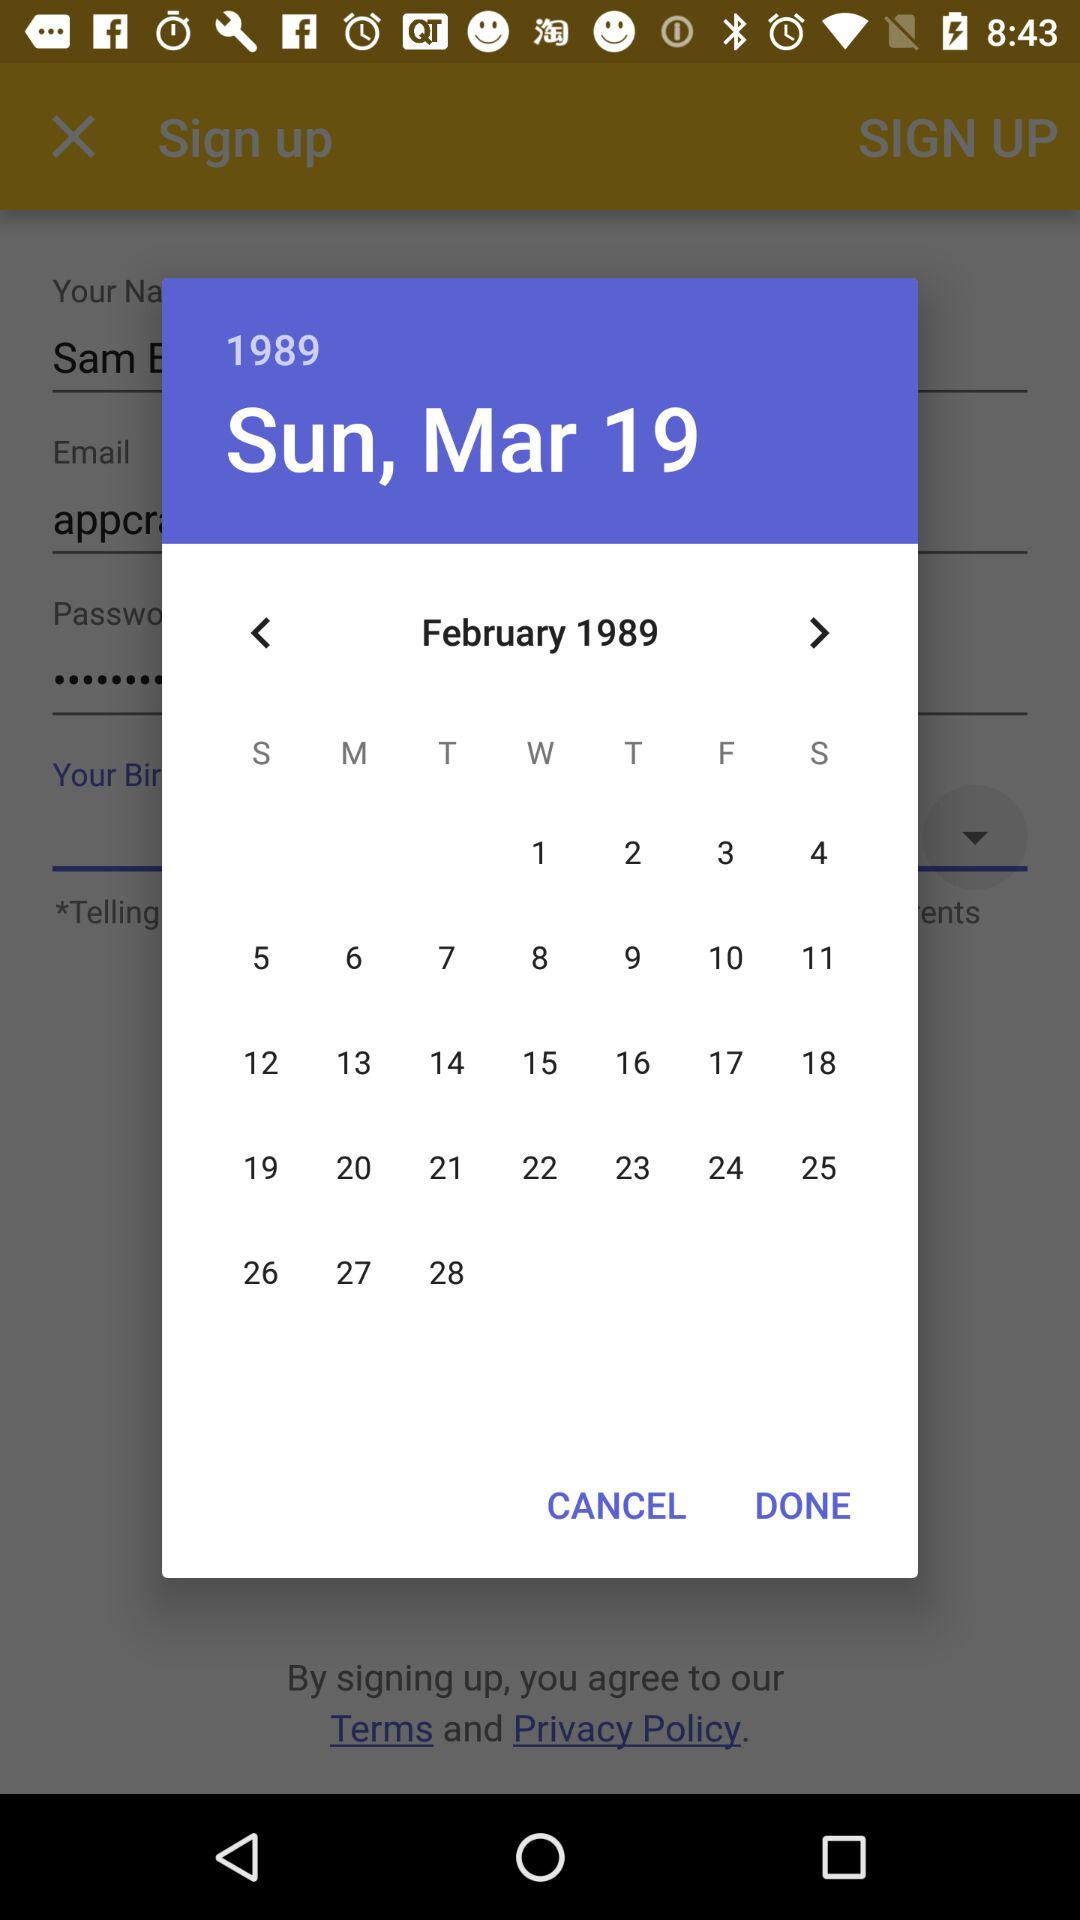What date is selected? The selected date is Sunday, March 19, 1989. 